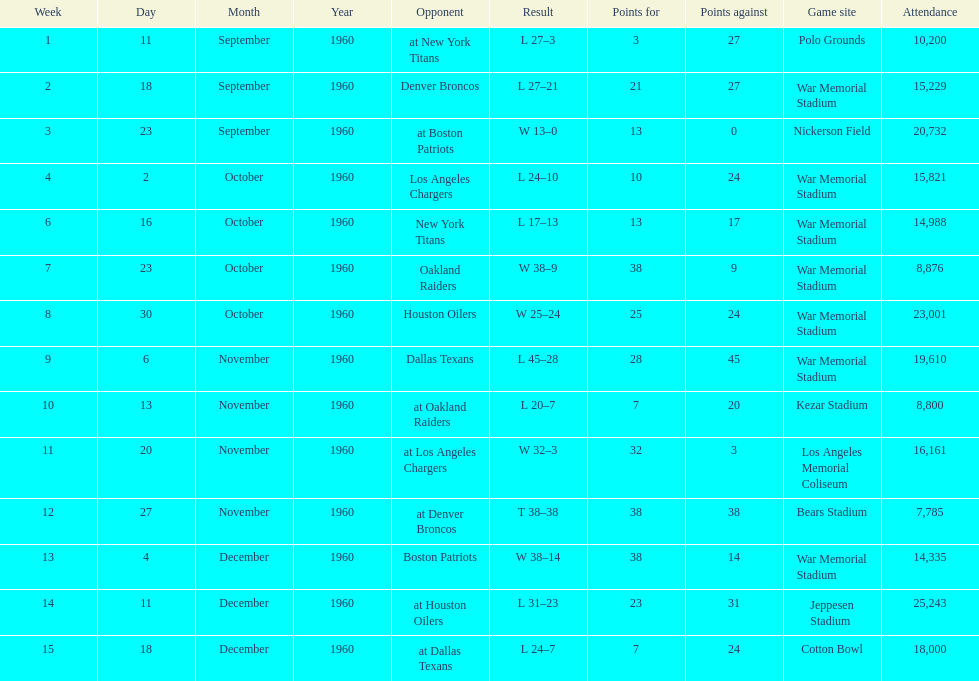Who was the only opponent they played which resulted in a tie game? Denver Broncos. 